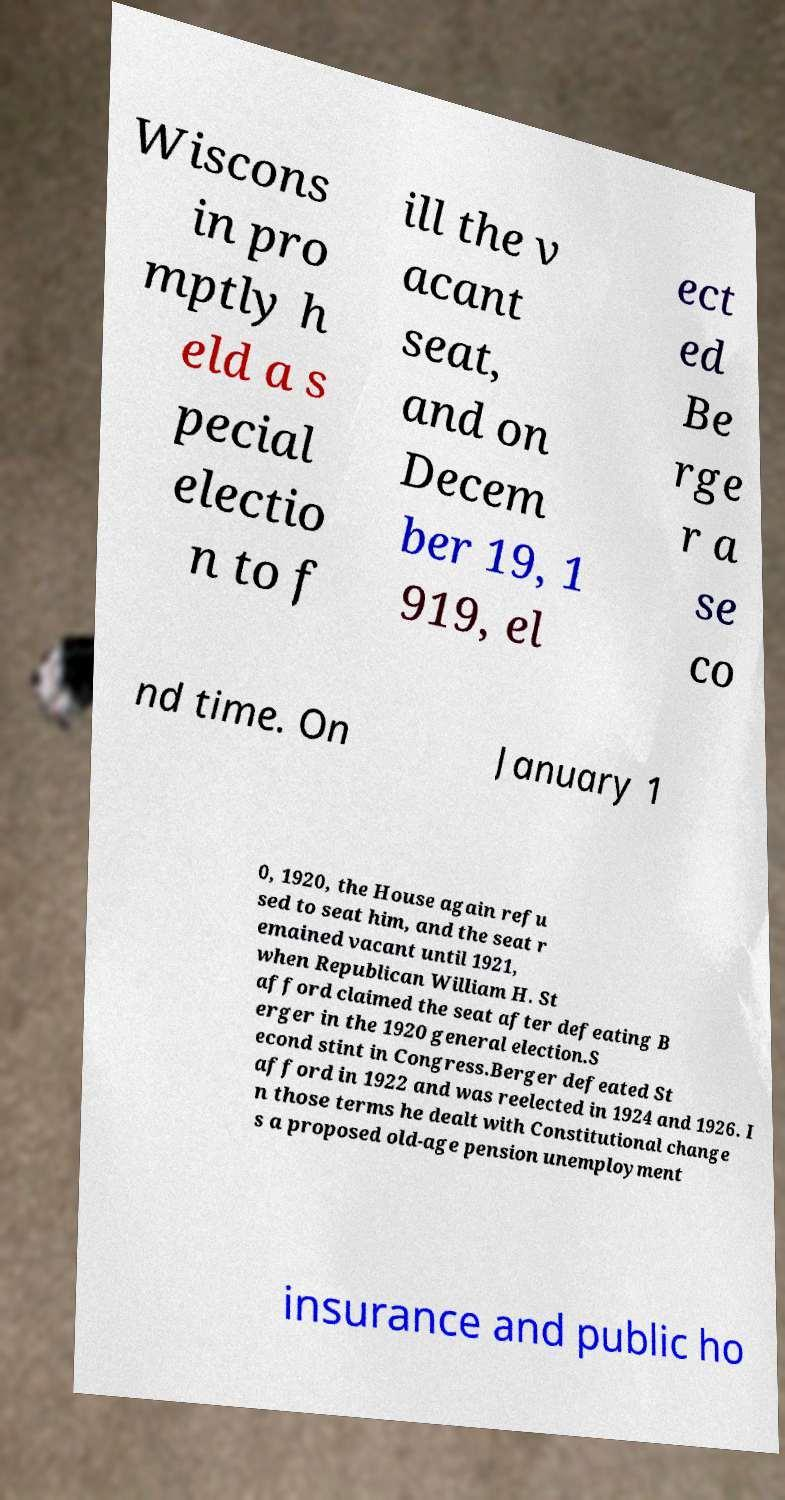Could you assist in decoding the text presented in this image and type it out clearly? Wiscons in pro mptly h eld a s pecial electio n to f ill the v acant seat, and on Decem ber 19, 1 919, el ect ed Be rge r a se co nd time. On January 1 0, 1920, the House again refu sed to seat him, and the seat r emained vacant until 1921, when Republican William H. St afford claimed the seat after defeating B erger in the 1920 general election.S econd stint in Congress.Berger defeated St afford in 1922 and was reelected in 1924 and 1926. I n those terms he dealt with Constitutional change s a proposed old-age pension unemployment insurance and public ho 